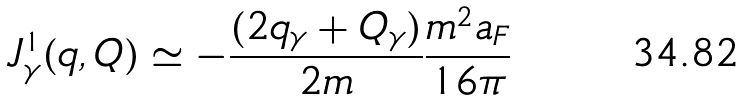Convert formula to latex. <formula><loc_0><loc_0><loc_500><loc_500>J _ { \gamma } ^ { 1 } ( q , Q ) \simeq - \frac { ( 2 q _ { \gamma } + Q _ { \gamma } ) } { 2 m } \frac { m ^ { 2 } a _ { F } } { 1 6 \pi }</formula> 